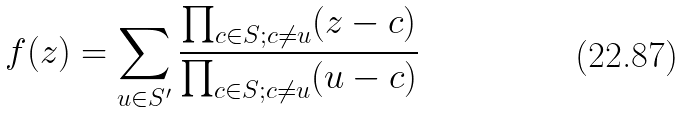Convert formula to latex. <formula><loc_0><loc_0><loc_500><loc_500>f ( z ) = \sum _ { u \in S ^ { \prime } } \frac { \prod _ { c \in S ; c \ne u } ( z - c ) } { \prod _ { c \in S ; c \ne u } ( u - c ) }</formula> 